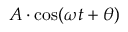Convert formula to latex. <formula><loc_0><loc_0><loc_500><loc_500>A \cdot \cos ( \omega t + \theta )</formula> 